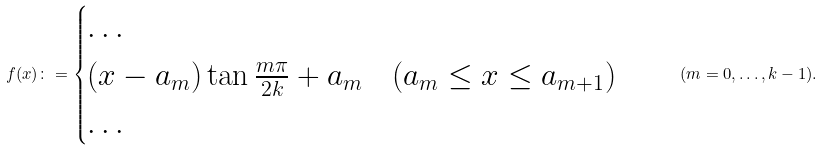Convert formula to latex. <formula><loc_0><loc_0><loc_500><loc_500>f ( x ) \colon = \begin{cases} \dots \\ ( x - a _ { m } ) \tan \frac { m \pi } { 2 k } + a _ { m } \quad ( a _ { m } \leq x \leq a _ { m + 1 } ) \\ \dots \end{cases} \quad ( m = 0 , \dots , k - 1 ) .</formula> 